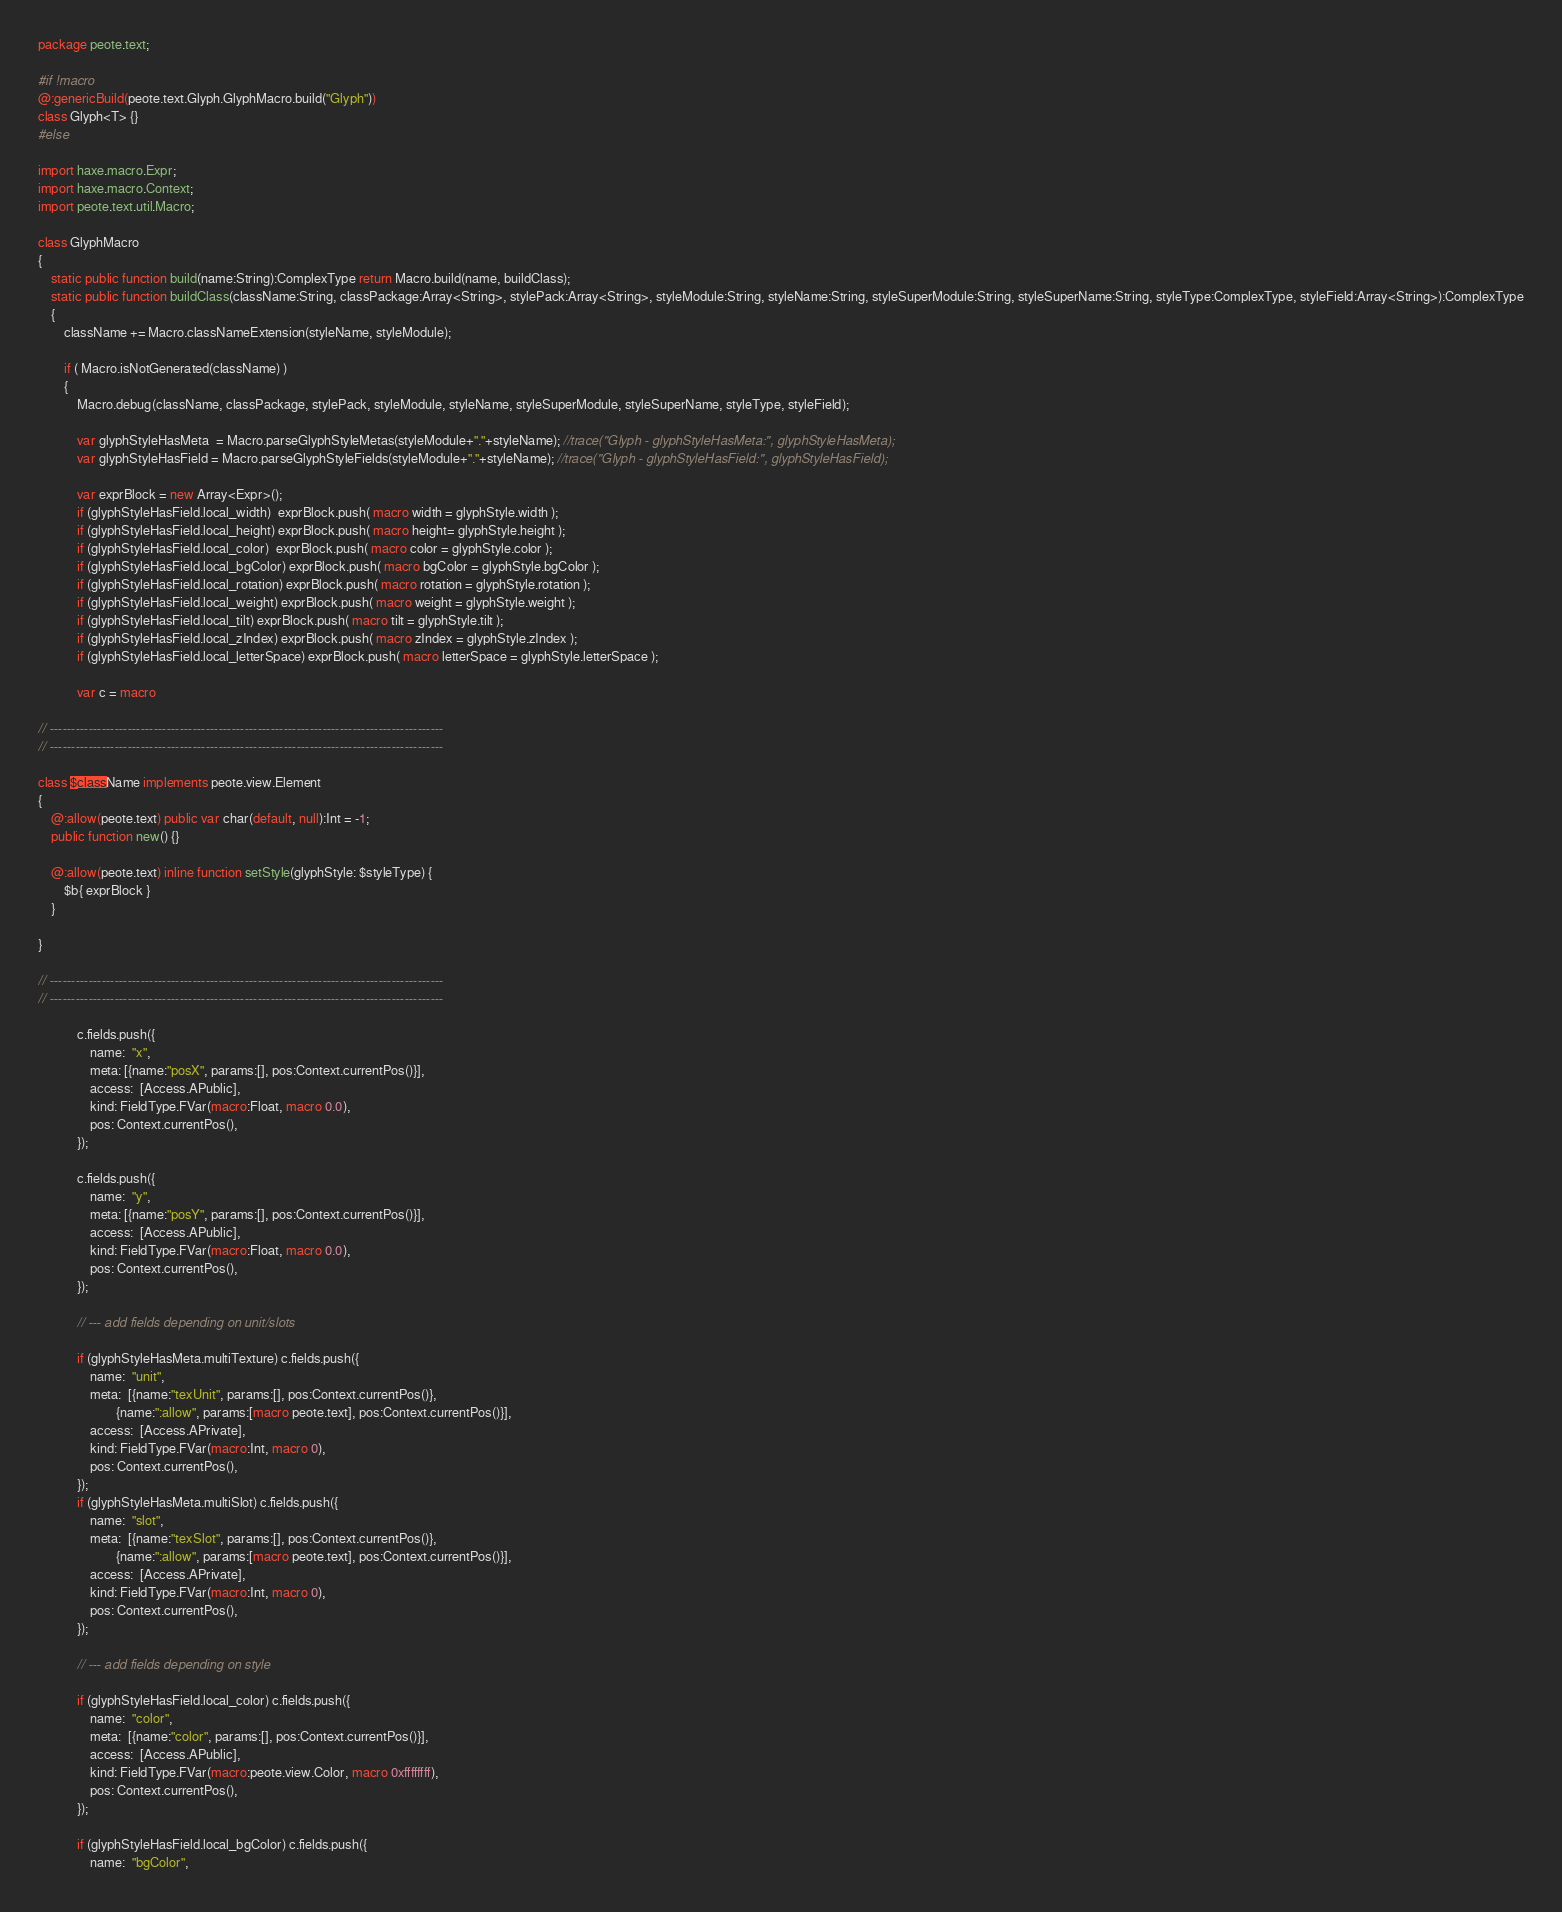Convert code to text. <code><loc_0><loc_0><loc_500><loc_500><_Haxe_>package peote.text;

#if !macro
@:genericBuild(peote.text.Glyph.GlyphMacro.build("Glyph"))
class Glyph<T> {}
#else

import haxe.macro.Expr;
import haxe.macro.Context;
import peote.text.util.Macro;

class GlyphMacro
{
	static public function build(name:String):ComplexType return Macro.build(name, buildClass);
	static public function buildClass(className:String, classPackage:Array<String>, stylePack:Array<String>, styleModule:String, styleName:String, styleSuperModule:String, styleSuperName:String, styleType:ComplexType, styleField:Array<String>):ComplexType
	{
		className += Macro.classNameExtension(styleName, styleModule);
		
		if ( Macro.isNotGenerated(className) )
		{
			Macro.debug(className, classPackage, stylePack, styleModule, styleName, styleSuperModule, styleSuperName, styleType, styleField);
						
			var glyphStyleHasMeta  = Macro.parseGlyphStyleMetas(styleModule+"."+styleName); //trace("Glyph - glyphStyleHasMeta:", glyphStyleHasMeta);
			var glyphStyleHasField = Macro.parseGlyphStyleFields(styleModule+"."+styleName); //trace("Glyph - glyphStyleHasField:", glyphStyleHasField);

			var exprBlock = new Array<Expr>();
			if (glyphStyleHasField.local_width)  exprBlock.push( macro width = glyphStyle.width );
			if (glyphStyleHasField.local_height) exprBlock.push( macro height= glyphStyle.height );
			if (glyphStyleHasField.local_color)  exprBlock.push( macro color = glyphStyle.color );
			if (glyphStyleHasField.local_bgColor) exprBlock.push( macro bgColor = glyphStyle.bgColor );
			if (glyphStyleHasField.local_rotation) exprBlock.push( macro rotation = glyphStyle.rotation );
			if (glyphStyleHasField.local_weight) exprBlock.push( macro weight = glyphStyle.weight );
			if (glyphStyleHasField.local_tilt) exprBlock.push( macro tilt = glyphStyle.tilt );
			if (glyphStyleHasField.local_zIndex) exprBlock.push( macro zIndex = glyphStyle.zIndex );
			if (glyphStyleHasField.local_letterSpace) exprBlock.push( macro letterSpace = glyphStyle.letterSpace );
			
			var c = macro

// -------------------------------------------------------------------------------------------
// -------------------------------------------------------------------------------------------

class $className implements peote.view.Element
{
	@:allow(peote.text) public var char(default, null):Int = -1;
	public function new() {}
	
	@:allow(peote.text) inline function setStyle(glyphStyle: $styleType) {
		$b{ exprBlock }
	}
	
}
			
// -------------------------------------------------------------------------------------------
// -------------------------------------------------------------------------------------------
						
			c.fields.push({
				name:  "x",
				meta: [{name:"posX", params:[], pos:Context.currentPos()}],
				access:  [Access.APublic],
				kind: FieldType.FVar(macro:Float, macro 0.0),
				pos: Context.currentPos(),
			});
			
			c.fields.push({
				name:  "y",
				meta: [{name:"posY", params:[], pos:Context.currentPos()}],
				access:  [Access.APublic],
				kind: FieldType.FVar(macro:Float, macro 0.0),
				pos: Context.currentPos(),
			});
			
			// --- add fields depending on unit/slots
			
			if (glyphStyleHasMeta.multiTexture) c.fields.push({
				name:  "unit",
				meta:  [{name:"texUnit", params:[], pos:Context.currentPos()},
						{name:":allow", params:[macro peote.text], pos:Context.currentPos()}],
				access:  [Access.APrivate],
				kind: FieldType.FVar(macro:Int, macro 0),
				pos: Context.currentPos(),
			});
			if (glyphStyleHasMeta.multiSlot) c.fields.push({
				name:  "slot",
				meta:  [{name:"texSlot", params:[], pos:Context.currentPos()},
						{name:":allow", params:[macro peote.text], pos:Context.currentPos()}],
				access:  [Access.APrivate],
				kind: FieldType.FVar(macro:Int, macro 0),
				pos: Context.currentPos(),
			});
			
			// --- add fields depending on style
			
			if (glyphStyleHasField.local_color) c.fields.push({
				name:  "color",
				meta:  [{name:"color", params:[], pos:Context.currentPos()}],
				access:  [Access.APublic],
				kind: FieldType.FVar(macro:peote.view.Color, macro 0xffffffff),
				pos: Context.currentPos(),
			});
			
			if (glyphStyleHasField.local_bgColor) c.fields.push({
				name:  "bgColor",</code> 